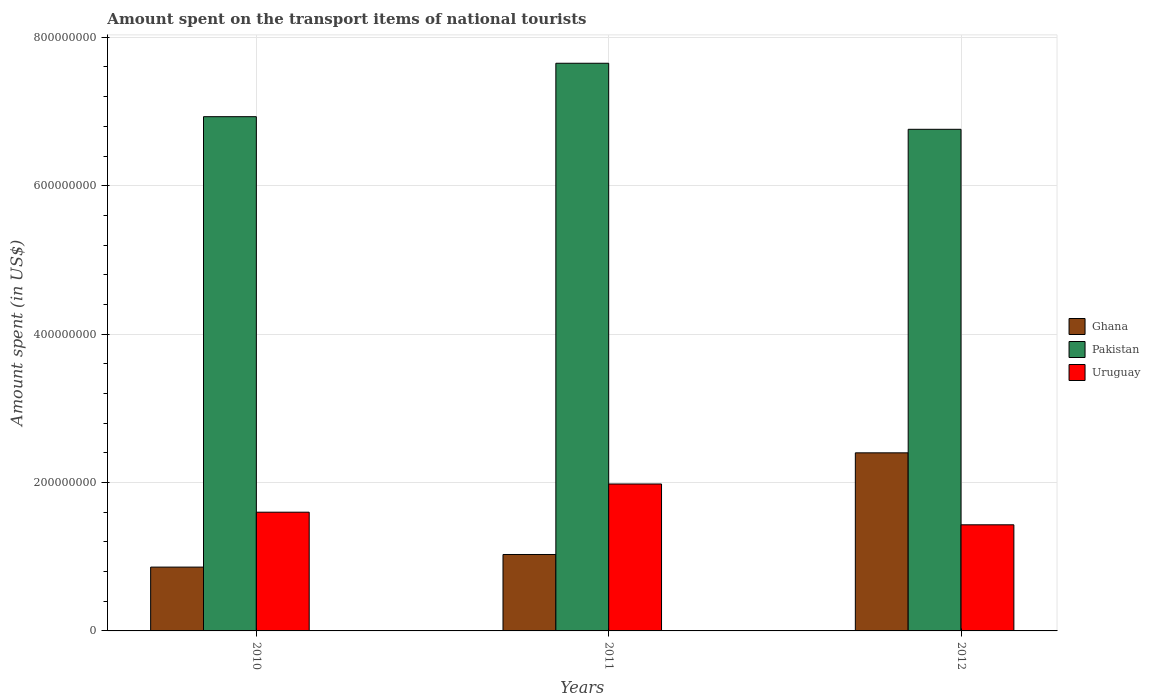How many groups of bars are there?
Your answer should be very brief. 3. Are the number of bars per tick equal to the number of legend labels?
Ensure brevity in your answer.  Yes. What is the label of the 3rd group of bars from the left?
Your answer should be very brief. 2012. What is the amount spent on the transport items of national tourists in Uruguay in 2012?
Offer a very short reply. 1.43e+08. Across all years, what is the maximum amount spent on the transport items of national tourists in Ghana?
Provide a short and direct response. 2.40e+08. Across all years, what is the minimum amount spent on the transport items of national tourists in Pakistan?
Ensure brevity in your answer.  6.76e+08. In which year was the amount spent on the transport items of national tourists in Ghana maximum?
Your response must be concise. 2012. In which year was the amount spent on the transport items of national tourists in Ghana minimum?
Provide a short and direct response. 2010. What is the total amount spent on the transport items of national tourists in Ghana in the graph?
Keep it short and to the point. 4.29e+08. What is the difference between the amount spent on the transport items of national tourists in Ghana in 2010 and that in 2011?
Your answer should be very brief. -1.70e+07. What is the difference between the amount spent on the transport items of national tourists in Uruguay in 2010 and the amount spent on the transport items of national tourists in Ghana in 2012?
Give a very brief answer. -8.00e+07. What is the average amount spent on the transport items of national tourists in Uruguay per year?
Your response must be concise. 1.67e+08. In the year 2010, what is the difference between the amount spent on the transport items of national tourists in Pakistan and amount spent on the transport items of national tourists in Ghana?
Your answer should be compact. 6.07e+08. In how many years, is the amount spent on the transport items of national tourists in Ghana greater than 400000000 US$?
Make the answer very short. 0. What is the ratio of the amount spent on the transport items of national tourists in Pakistan in 2010 to that in 2011?
Give a very brief answer. 0.91. Is the difference between the amount spent on the transport items of national tourists in Pakistan in 2010 and 2012 greater than the difference between the amount spent on the transport items of national tourists in Ghana in 2010 and 2012?
Provide a succinct answer. Yes. What is the difference between the highest and the second highest amount spent on the transport items of national tourists in Ghana?
Offer a very short reply. 1.37e+08. What is the difference between the highest and the lowest amount spent on the transport items of national tourists in Uruguay?
Your answer should be very brief. 5.50e+07. In how many years, is the amount spent on the transport items of national tourists in Ghana greater than the average amount spent on the transport items of national tourists in Ghana taken over all years?
Offer a very short reply. 1. What does the 3rd bar from the left in 2010 represents?
Your answer should be very brief. Uruguay. What does the 2nd bar from the right in 2011 represents?
Your answer should be compact. Pakistan. Is it the case that in every year, the sum of the amount spent on the transport items of national tourists in Uruguay and amount spent on the transport items of national tourists in Pakistan is greater than the amount spent on the transport items of national tourists in Ghana?
Your answer should be compact. Yes. Where does the legend appear in the graph?
Your answer should be compact. Center right. How many legend labels are there?
Provide a succinct answer. 3. What is the title of the graph?
Provide a succinct answer. Amount spent on the transport items of national tourists. Does "Europe(all income levels)" appear as one of the legend labels in the graph?
Keep it short and to the point. No. What is the label or title of the Y-axis?
Provide a short and direct response. Amount spent (in US$). What is the Amount spent (in US$) in Ghana in 2010?
Your response must be concise. 8.60e+07. What is the Amount spent (in US$) of Pakistan in 2010?
Make the answer very short. 6.93e+08. What is the Amount spent (in US$) of Uruguay in 2010?
Keep it short and to the point. 1.60e+08. What is the Amount spent (in US$) of Ghana in 2011?
Offer a terse response. 1.03e+08. What is the Amount spent (in US$) in Pakistan in 2011?
Provide a short and direct response. 7.65e+08. What is the Amount spent (in US$) in Uruguay in 2011?
Ensure brevity in your answer.  1.98e+08. What is the Amount spent (in US$) of Ghana in 2012?
Offer a terse response. 2.40e+08. What is the Amount spent (in US$) of Pakistan in 2012?
Offer a terse response. 6.76e+08. What is the Amount spent (in US$) in Uruguay in 2012?
Offer a very short reply. 1.43e+08. Across all years, what is the maximum Amount spent (in US$) of Ghana?
Your response must be concise. 2.40e+08. Across all years, what is the maximum Amount spent (in US$) of Pakistan?
Offer a very short reply. 7.65e+08. Across all years, what is the maximum Amount spent (in US$) of Uruguay?
Keep it short and to the point. 1.98e+08. Across all years, what is the minimum Amount spent (in US$) of Ghana?
Keep it short and to the point. 8.60e+07. Across all years, what is the minimum Amount spent (in US$) in Pakistan?
Offer a very short reply. 6.76e+08. Across all years, what is the minimum Amount spent (in US$) of Uruguay?
Your answer should be compact. 1.43e+08. What is the total Amount spent (in US$) in Ghana in the graph?
Ensure brevity in your answer.  4.29e+08. What is the total Amount spent (in US$) in Pakistan in the graph?
Your answer should be compact. 2.13e+09. What is the total Amount spent (in US$) in Uruguay in the graph?
Ensure brevity in your answer.  5.01e+08. What is the difference between the Amount spent (in US$) in Ghana in 2010 and that in 2011?
Offer a terse response. -1.70e+07. What is the difference between the Amount spent (in US$) in Pakistan in 2010 and that in 2011?
Your response must be concise. -7.20e+07. What is the difference between the Amount spent (in US$) of Uruguay in 2010 and that in 2011?
Your answer should be compact. -3.80e+07. What is the difference between the Amount spent (in US$) of Ghana in 2010 and that in 2012?
Offer a very short reply. -1.54e+08. What is the difference between the Amount spent (in US$) of Pakistan in 2010 and that in 2012?
Give a very brief answer. 1.70e+07. What is the difference between the Amount spent (in US$) in Uruguay in 2010 and that in 2012?
Your response must be concise. 1.70e+07. What is the difference between the Amount spent (in US$) in Ghana in 2011 and that in 2012?
Ensure brevity in your answer.  -1.37e+08. What is the difference between the Amount spent (in US$) of Pakistan in 2011 and that in 2012?
Your answer should be compact. 8.90e+07. What is the difference between the Amount spent (in US$) of Uruguay in 2011 and that in 2012?
Offer a terse response. 5.50e+07. What is the difference between the Amount spent (in US$) in Ghana in 2010 and the Amount spent (in US$) in Pakistan in 2011?
Make the answer very short. -6.79e+08. What is the difference between the Amount spent (in US$) in Ghana in 2010 and the Amount spent (in US$) in Uruguay in 2011?
Your response must be concise. -1.12e+08. What is the difference between the Amount spent (in US$) of Pakistan in 2010 and the Amount spent (in US$) of Uruguay in 2011?
Give a very brief answer. 4.95e+08. What is the difference between the Amount spent (in US$) in Ghana in 2010 and the Amount spent (in US$) in Pakistan in 2012?
Provide a succinct answer. -5.90e+08. What is the difference between the Amount spent (in US$) of Ghana in 2010 and the Amount spent (in US$) of Uruguay in 2012?
Provide a succinct answer. -5.70e+07. What is the difference between the Amount spent (in US$) of Pakistan in 2010 and the Amount spent (in US$) of Uruguay in 2012?
Give a very brief answer. 5.50e+08. What is the difference between the Amount spent (in US$) of Ghana in 2011 and the Amount spent (in US$) of Pakistan in 2012?
Provide a succinct answer. -5.73e+08. What is the difference between the Amount spent (in US$) in Ghana in 2011 and the Amount spent (in US$) in Uruguay in 2012?
Your answer should be very brief. -4.00e+07. What is the difference between the Amount spent (in US$) in Pakistan in 2011 and the Amount spent (in US$) in Uruguay in 2012?
Your answer should be compact. 6.22e+08. What is the average Amount spent (in US$) of Ghana per year?
Offer a terse response. 1.43e+08. What is the average Amount spent (in US$) in Pakistan per year?
Offer a very short reply. 7.11e+08. What is the average Amount spent (in US$) in Uruguay per year?
Your answer should be compact. 1.67e+08. In the year 2010, what is the difference between the Amount spent (in US$) of Ghana and Amount spent (in US$) of Pakistan?
Provide a succinct answer. -6.07e+08. In the year 2010, what is the difference between the Amount spent (in US$) in Ghana and Amount spent (in US$) in Uruguay?
Your response must be concise. -7.40e+07. In the year 2010, what is the difference between the Amount spent (in US$) of Pakistan and Amount spent (in US$) of Uruguay?
Offer a very short reply. 5.33e+08. In the year 2011, what is the difference between the Amount spent (in US$) in Ghana and Amount spent (in US$) in Pakistan?
Your response must be concise. -6.62e+08. In the year 2011, what is the difference between the Amount spent (in US$) in Ghana and Amount spent (in US$) in Uruguay?
Offer a very short reply. -9.50e+07. In the year 2011, what is the difference between the Amount spent (in US$) in Pakistan and Amount spent (in US$) in Uruguay?
Provide a short and direct response. 5.67e+08. In the year 2012, what is the difference between the Amount spent (in US$) of Ghana and Amount spent (in US$) of Pakistan?
Offer a terse response. -4.36e+08. In the year 2012, what is the difference between the Amount spent (in US$) of Ghana and Amount spent (in US$) of Uruguay?
Give a very brief answer. 9.70e+07. In the year 2012, what is the difference between the Amount spent (in US$) in Pakistan and Amount spent (in US$) in Uruguay?
Offer a very short reply. 5.33e+08. What is the ratio of the Amount spent (in US$) in Ghana in 2010 to that in 2011?
Give a very brief answer. 0.83. What is the ratio of the Amount spent (in US$) in Pakistan in 2010 to that in 2011?
Your answer should be very brief. 0.91. What is the ratio of the Amount spent (in US$) of Uruguay in 2010 to that in 2011?
Offer a very short reply. 0.81. What is the ratio of the Amount spent (in US$) in Ghana in 2010 to that in 2012?
Offer a very short reply. 0.36. What is the ratio of the Amount spent (in US$) of Pakistan in 2010 to that in 2012?
Ensure brevity in your answer.  1.03. What is the ratio of the Amount spent (in US$) of Uruguay in 2010 to that in 2012?
Your answer should be compact. 1.12. What is the ratio of the Amount spent (in US$) in Ghana in 2011 to that in 2012?
Provide a succinct answer. 0.43. What is the ratio of the Amount spent (in US$) of Pakistan in 2011 to that in 2012?
Ensure brevity in your answer.  1.13. What is the ratio of the Amount spent (in US$) in Uruguay in 2011 to that in 2012?
Ensure brevity in your answer.  1.38. What is the difference between the highest and the second highest Amount spent (in US$) in Ghana?
Your answer should be compact. 1.37e+08. What is the difference between the highest and the second highest Amount spent (in US$) of Pakistan?
Keep it short and to the point. 7.20e+07. What is the difference between the highest and the second highest Amount spent (in US$) in Uruguay?
Provide a succinct answer. 3.80e+07. What is the difference between the highest and the lowest Amount spent (in US$) in Ghana?
Offer a terse response. 1.54e+08. What is the difference between the highest and the lowest Amount spent (in US$) in Pakistan?
Your answer should be very brief. 8.90e+07. What is the difference between the highest and the lowest Amount spent (in US$) in Uruguay?
Your response must be concise. 5.50e+07. 